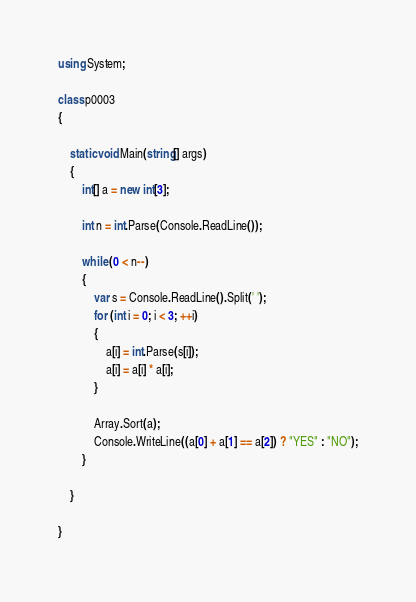Convert code to text. <code><loc_0><loc_0><loc_500><loc_500><_C#_>
using System;

class p0003
{

    static void Main(string[] args)
    {
        int[] a = new int[3];

        int n = int.Parse(Console.ReadLine());

        while (0 < n--)
        {
            var s = Console.ReadLine().Split(' ');
            for (int i = 0; i < 3; ++i)
            {
                a[i] = int.Parse(s[i]);
                a[i] = a[i] * a[i];
            }

            Array.Sort(a);
            Console.WriteLine((a[0] + a[1] == a[2]) ? "YES" : "NO");
        }

    }
    
}</code> 